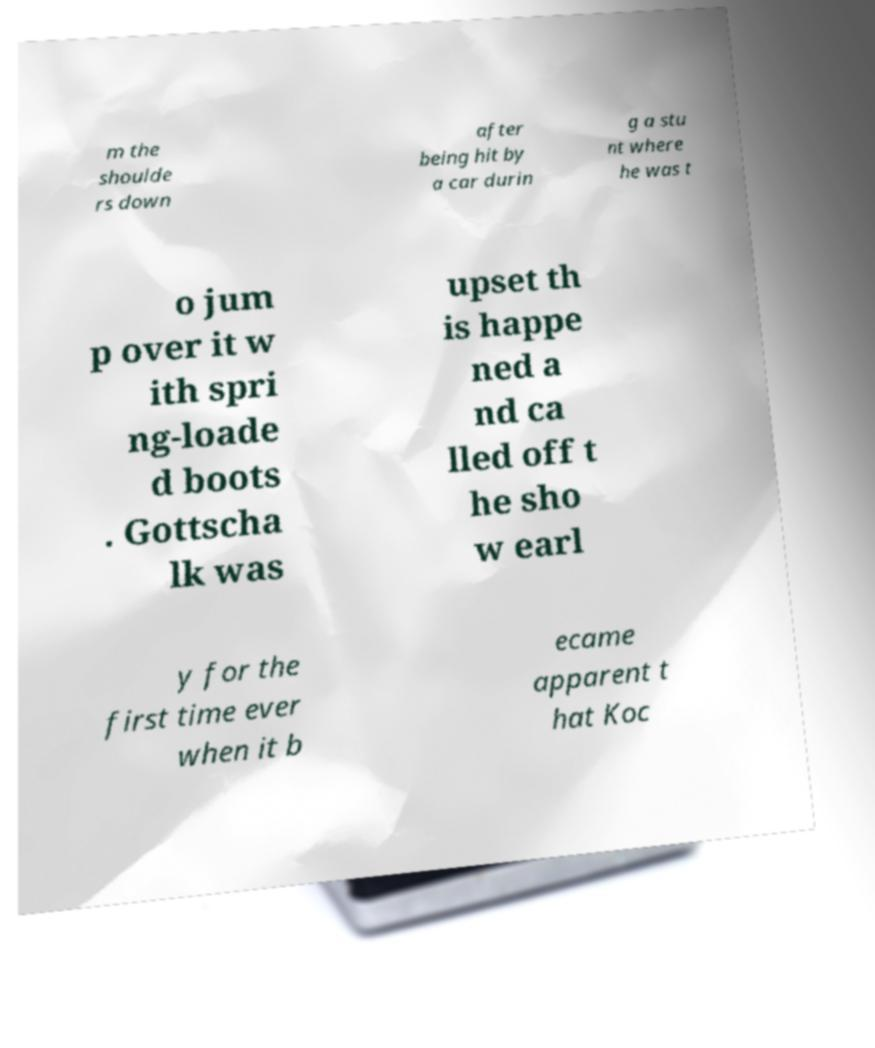There's text embedded in this image that I need extracted. Can you transcribe it verbatim? m the shoulde rs down after being hit by a car durin g a stu nt where he was t o jum p over it w ith spri ng-loade d boots . Gottscha lk was upset th is happe ned a nd ca lled off t he sho w earl y for the first time ever when it b ecame apparent t hat Koc 